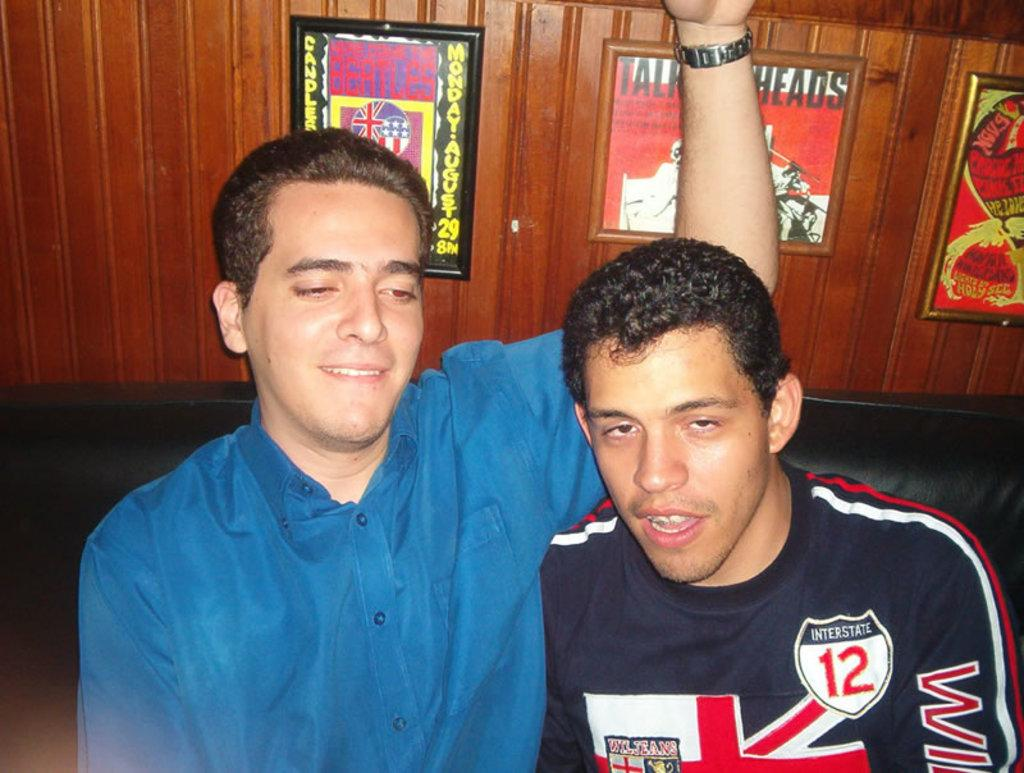How many people are in the image? There are two men in the image. What is the man in the blue shirt wearing? The man in the blue shirt is wearing a blue shirt. What is the facial expression of the man in the blue shirt? The man in the blue shirt is smiling. Where are the men sitting in the image? The men are sitting on a sofa. What can be seen on the wall in the background? There are photo frames on the wall in the background. How does the pollution affect the eyes of the men in the image? There is no mention of pollution in the image, so it cannot be determined how it might affect the men's eyes. 